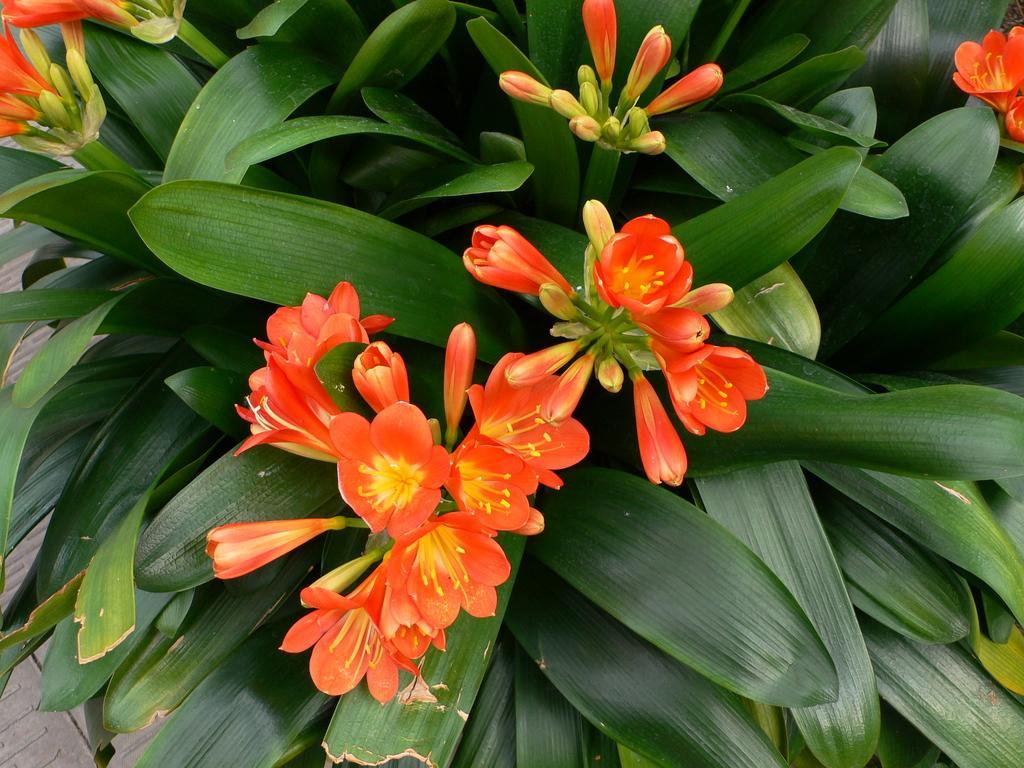Please provide a concise description of this image. In the center of the image there are flowers. There are leaves. 